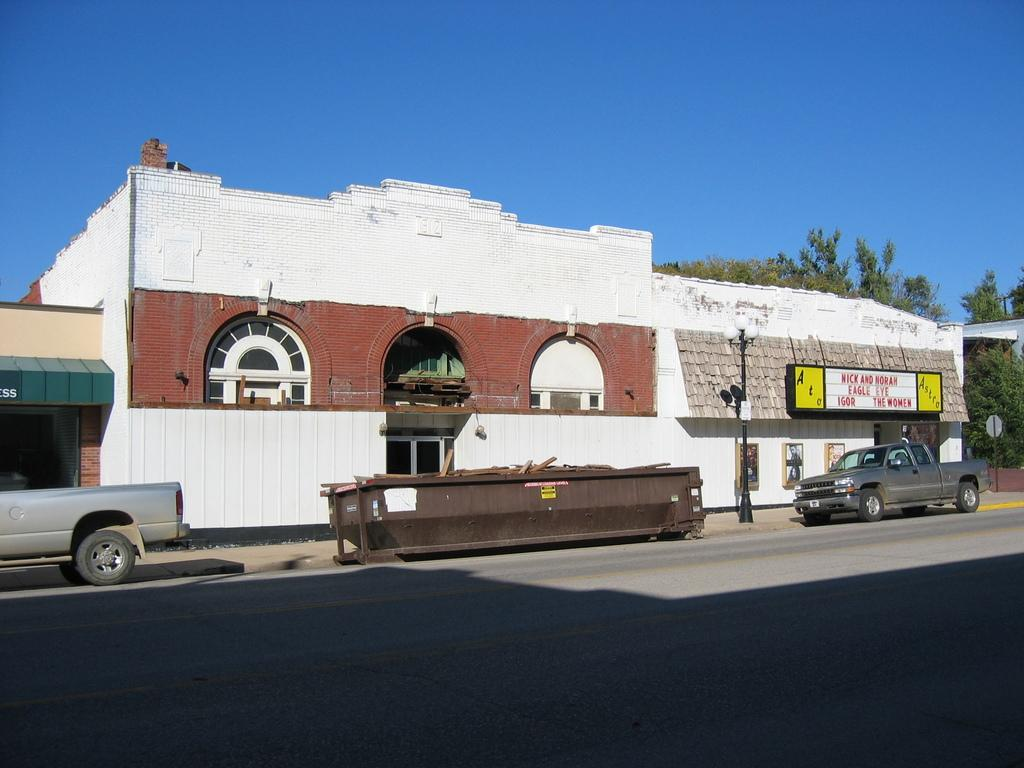What type of structure is visible in the image? There is a building in the image. Where is the first car located in the image? The first car is on the left side of the image. Where is the second car located in the image? The second car is on the right side of the image. What is the primary feature of the image's setting? There is a roadway in the image. What type of temper does the building in the image have? The building in the image does not have a temper, as it is an inanimate object. 